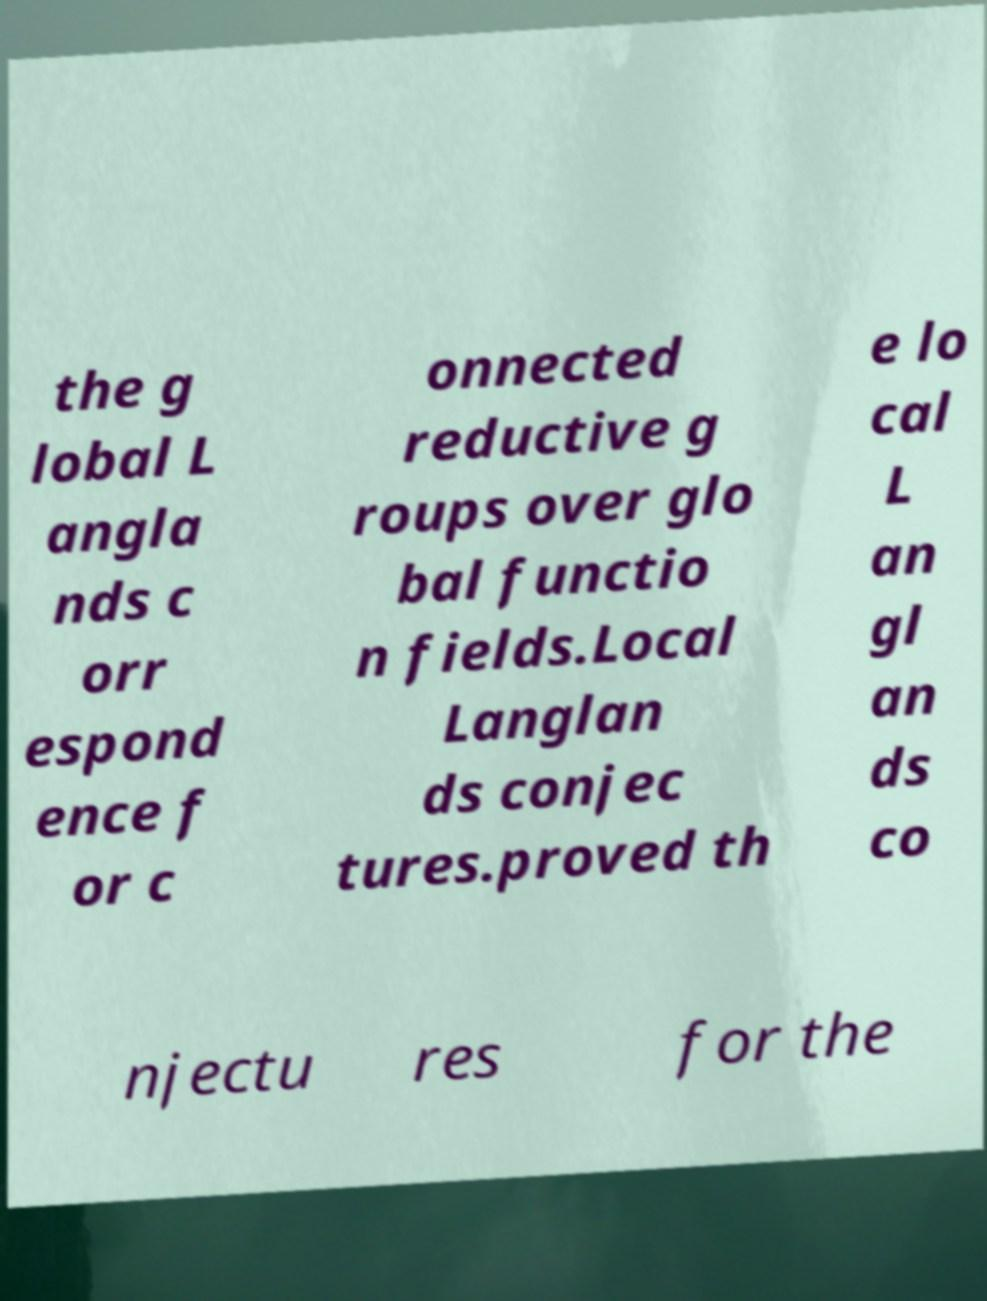For documentation purposes, I need the text within this image transcribed. Could you provide that? the g lobal L angla nds c orr espond ence f or c onnected reductive g roups over glo bal functio n fields.Local Langlan ds conjec tures.proved th e lo cal L an gl an ds co njectu res for the 